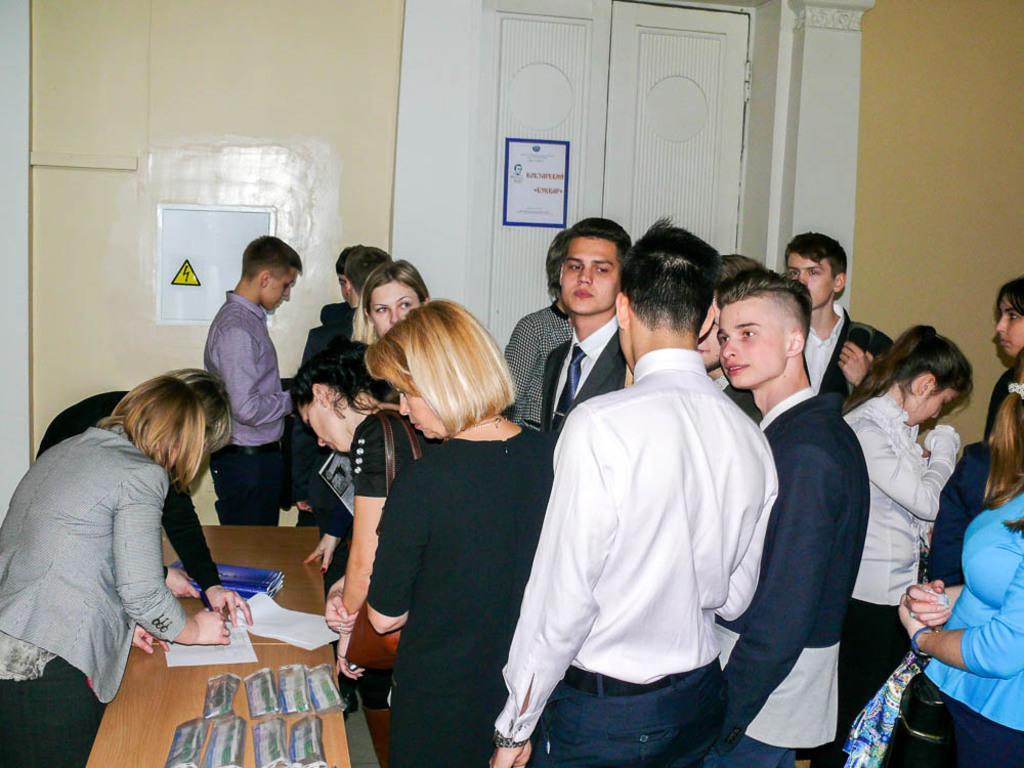Can you describe this image briefly? In this picture we can see a group of people standing on the floor and in front of the people there is a table and on the table there are papers and other things. Behind the people there is a wall and a door. 